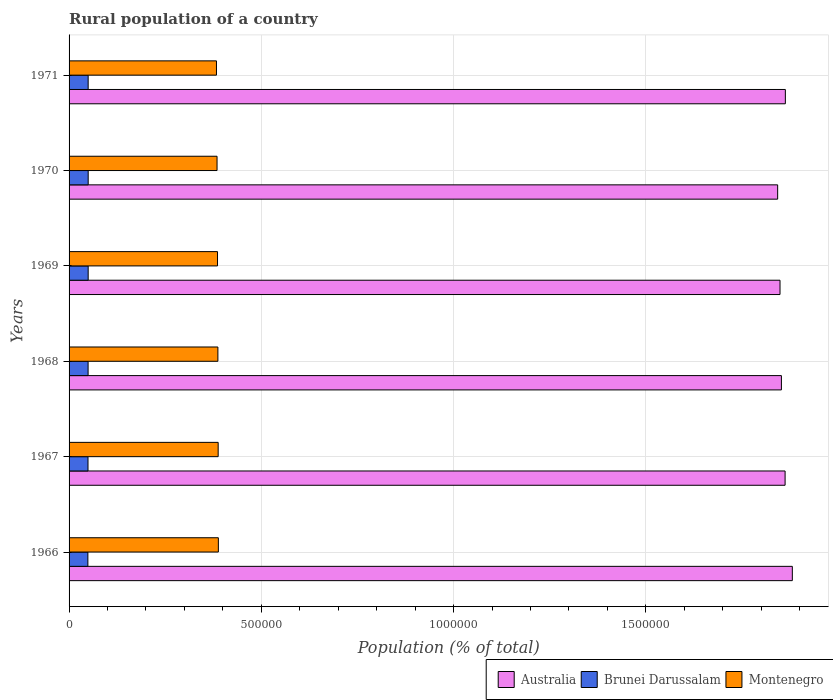How many groups of bars are there?
Make the answer very short. 6. Are the number of bars per tick equal to the number of legend labels?
Your answer should be very brief. Yes. How many bars are there on the 2nd tick from the bottom?
Keep it short and to the point. 3. What is the label of the 3rd group of bars from the top?
Provide a short and direct response. 1969. What is the rural population in Brunei Darussalam in 1970?
Your answer should be very brief. 4.97e+04. Across all years, what is the maximum rural population in Australia?
Give a very brief answer. 1.88e+06. Across all years, what is the minimum rural population in Brunei Darussalam?
Keep it short and to the point. 4.89e+04. In which year was the rural population in Montenegro maximum?
Give a very brief answer. 1966. In which year was the rural population in Australia minimum?
Give a very brief answer. 1970. What is the total rural population in Australia in the graph?
Give a very brief answer. 1.12e+07. What is the difference between the rural population in Brunei Darussalam in 1969 and that in 1970?
Your answer should be compact. -55. What is the difference between the rural population in Brunei Darussalam in 1969 and the rural population in Australia in 1968?
Your answer should be very brief. -1.80e+06. What is the average rural population in Brunei Darussalam per year?
Keep it short and to the point. 4.94e+04. In the year 1967, what is the difference between the rural population in Brunei Darussalam and rural population in Montenegro?
Your response must be concise. -3.39e+05. In how many years, is the rural population in Brunei Darussalam greater than 600000 %?
Make the answer very short. 0. What is the ratio of the rural population in Australia in 1967 to that in 1969?
Provide a short and direct response. 1.01. What is the difference between the highest and the second highest rural population in Montenegro?
Your answer should be compact. 488. What is the difference between the highest and the lowest rural population in Brunei Darussalam?
Your answer should be very brief. 796. In how many years, is the rural population in Australia greater than the average rural population in Australia taken over all years?
Give a very brief answer. 3. Is the sum of the rural population in Australia in 1969 and 1971 greater than the maximum rural population in Brunei Darussalam across all years?
Provide a short and direct response. Yes. What does the 2nd bar from the top in 1971 represents?
Keep it short and to the point. Brunei Darussalam. What does the 2nd bar from the bottom in 1967 represents?
Keep it short and to the point. Brunei Darussalam. Are all the bars in the graph horizontal?
Your answer should be compact. Yes. Where does the legend appear in the graph?
Keep it short and to the point. Bottom right. How are the legend labels stacked?
Keep it short and to the point. Horizontal. What is the title of the graph?
Your response must be concise. Rural population of a country. Does "Lao PDR" appear as one of the legend labels in the graph?
Give a very brief answer. No. What is the label or title of the X-axis?
Ensure brevity in your answer.  Population (% of total). What is the label or title of the Y-axis?
Your answer should be compact. Years. What is the Population (% of total) in Australia in 1966?
Your response must be concise. 1.88e+06. What is the Population (% of total) in Brunei Darussalam in 1966?
Offer a terse response. 4.89e+04. What is the Population (% of total) in Montenegro in 1966?
Offer a very short reply. 3.88e+05. What is the Population (% of total) of Australia in 1967?
Offer a very short reply. 1.86e+06. What is the Population (% of total) in Brunei Darussalam in 1967?
Your answer should be compact. 4.92e+04. What is the Population (% of total) in Montenegro in 1967?
Provide a short and direct response. 3.88e+05. What is the Population (% of total) in Australia in 1968?
Ensure brevity in your answer.  1.85e+06. What is the Population (% of total) of Brunei Darussalam in 1968?
Your answer should be compact. 4.95e+04. What is the Population (% of total) of Montenegro in 1968?
Ensure brevity in your answer.  3.87e+05. What is the Population (% of total) in Australia in 1969?
Your response must be concise. 1.85e+06. What is the Population (% of total) in Brunei Darussalam in 1969?
Your response must be concise. 4.97e+04. What is the Population (% of total) in Montenegro in 1969?
Provide a succinct answer. 3.86e+05. What is the Population (% of total) in Australia in 1970?
Your answer should be compact. 1.84e+06. What is the Population (% of total) in Brunei Darussalam in 1970?
Give a very brief answer. 4.97e+04. What is the Population (% of total) in Montenegro in 1970?
Your response must be concise. 3.85e+05. What is the Population (% of total) of Australia in 1971?
Keep it short and to the point. 1.86e+06. What is the Population (% of total) of Brunei Darussalam in 1971?
Your response must be concise. 4.97e+04. What is the Population (% of total) of Montenegro in 1971?
Offer a terse response. 3.83e+05. Across all years, what is the maximum Population (% of total) of Australia?
Give a very brief answer. 1.88e+06. Across all years, what is the maximum Population (% of total) in Brunei Darussalam?
Make the answer very short. 4.97e+04. Across all years, what is the maximum Population (% of total) of Montenegro?
Ensure brevity in your answer.  3.88e+05. Across all years, what is the minimum Population (% of total) in Australia?
Provide a short and direct response. 1.84e+06. Across all years, what is the minimum Population (% of total) of Brunei Darussalam?
Your answer should be very brief. 4.89e+04. Across all years, what is the minimum Population (% of total) of Montenegro?
Provide a succinct answer. 3.83e+05. What is the total Population (% of total) in Australia in the graph?
Your answer should be very brief. 1.12e+07. What is the total Population (% of total) in Brunei Darussalam in the graph?
Your answer should be compact. 2.97e+05. What is the total Population (% of total) in Montenegro in the graph?
Your answer should be compact. 2.32e+06. What is the difference between the Population (% of total) of Australia in 1966 and that in 1967?
Provide a short and direct response. 1.88e+04. What is the difference between the Population (% of total) of Brunei Darussalam in 1966 and that in 1967?
Offer a terse response. -318. What is the difference between the Population (% of total) of Montenegro in 1966 and that in 1967?
Give a very brief answer. 488. What is the difference between the Population (% of total) of Australia in 1966 and that in 1968?
Ensure brevity in your answer.  2.84e+04. What is the difference between the Population (% of total) in Brunei Darussalam in 1966 and that in 1968?
Provide a succinct answer. -571. What is the difference between the Population (% of total) of Montenegro in 1966 and that in 1968?
Provide a succinct answer. 1223. What is the difference between the Population (% of total) in Australia in 1966 and that in 1969?
Offer a terse response. 3.20e+04. What is the difference between the Population (% of total) of Brunei Darussalam in 1966 and that in 1969?
Make the answer very short. -741. What is the difference between the Population (% of total) in Montenegro in 1966 and that in 1969?
Ensure brevity in your answer.  2198. What is the difference between the Population (% of total) in Australia in 1966 and that in 1970?
Your answer should be very brief. 3.81e+04. What is the difference between the Population (% of total) of Brunei Darussalam in 1966 and that in 1970?
Keep it short and to the point. -796. What is the difference between the Population (% of total) of Montenegro in 1966 and that in 1970?
Provide a succinct answer. 3443. What is the difference between the Population (% of total) in Australia in 1966 and that in 1971?
Keep it short and to the point. 1.81e+04. What is the difference between the Population (% of total) of Brunei Darussalam in 1966 and that in 1971?
Keep it short and to the point. -733. What is the difference between the Population (% of total) of Montenegro in 1966 and that in 1971?
Offer a very short reply. 4952. What is the difference between the Population (% of total) of Australia in 1967 and that in 1968?
Your response must be concise. 9608. What is the difference between the Population (% of total) of Brunei Darussalam in 1967 and that in 1968?
Provide a short and direct response. -253. What is the difference between the Population (% of total) of Montenegro in 1967 and that in 1968?
Ensure brevity in your answer.  735. What is the difference between the Population (% of total) in Australia in 1967 and that in 1969?
Offer a very short reply. 1.32e+04. What is the difference between the Population (% of total) in Brunei Darussalam in 1967 and that in 1969?
Make the answer very short. -423. What is the difference between the Population (% of total) in Montenegro in 1967 and that in 1969?
Make the answer very short. 1710. What is the difference between the Population (% of total) in Australia in 1967 and that in 1970?
Provide a succinct answer. 1.93e+04. What is the difference between the Population (% of total) of Brunei Darussalam in 1967 and that in 1970?
Your response must be concise. -478. What is the difference between the Population (% of total) of Montenegro in 1967 and that in 1970?
Provide a succinct answer. 2955. What is the difference between the Population (% of total) of Australia in 1967 and that in 1971?
Provide a short and direct response. -692. What is the difference between the Population (% of total) of Brunei Darussalam in 1967 and that in 1971?
Give a very brief answer. -415. What is the difference between the Population (% of total) in Montenegro in 1967 and that in 1971?
Your response must be concise. 4464. What is the difference between the Population (% of total) in Australia in 1968 and that in 1969?
Your response must be concise. 3613. What is the difference between the Population (% of total) of Brunei Darussalam in 1968 and that in 1969?
Offer a very short reply. -170. What is the difference between the Population (% of total) of Montenegro in 1968 and that in 1969?
Make the answer very short. 975. What is the difference between the Population (% of total) in Australia in 1968 and that in 1970?
Provide a short and direct response. 9722. What is the difference between the Population (% of total) of Brunei Darussalam in 1968 and that in 1970?
Ensure brevity in your answer.  -225. What is the difference between the Population (% of total) of Montenegro in 1968 and that in 1970?
Offer a terse response. 2220. What is the difference between the Population (% of total) in Australia in 1968 and that in 1971?
Make the answer very short. -1.03e+04. What is the difference between the Population (% of total) in Brunei Darussalam in 1968 and that in 1971?
Offer a very short reply. -162. What is the difference between the Population (% of total) in Montenegro in 1968 and that in 1971?
Ensure brevity in your answer.  3729. What is the difference between the Population (% of total) of Australia in 1969 and that in 1970?
Your answer should be compact. 6109. What is the difference between the Population (% of total) of Brunei Darussalam in 1969 and that in 1970?
Make the answer very short. -55. What is the difference between the Population (% of total) in Montenegro in 1969 and that in 1970?
Make the answer very short. 1245. What is the difference between the Population (% of total) of Australia in 1969 and that in 1971?
Offer a very short reply. -1.39e+04. What is the difference between the Population (% of total) in Brunei Darussalam in 1969 and that in 1971?
Provide a succinct answer. 8. What is the difference between the Population (% of total) in Montenegro in 1969 and that in 1971?
Your answer should be compact. 2754. What is the difference between the Population (% of total) of Australia in 1970 and that in 1971?
Provide a short and direct response. -2.00e+04. What is the difference between the Population (% of total) in Brunei Darussalam in 1970 and that in 1971?
Offer a very short reply. 63. What is the difference between the Population (% of total) in Montenegro in 1970 and that in 1971?
Make the answer very short. 1509. What is the difference between the Population (% of total) of Australia in 1966 and the Population (% of total) of Brunei Darussalam in 1967?
Provide a succinct answer. 1.83e+06. What is the difference between the Population (% of total) in Australia in 1966 and the Population (% of total) in Montenegro in 1967?
Make the answer very short. 1.49e+06. What is the difference between the Population (% of total) of Brunei Darussalam in 1966 and the Population (% of total) of Montenegro in 1967?
Provide a short and direct response. -3.39e+05. What is the difference between the Population (% of total) of Australia in 1966 and the Population (% of total) of Brunei Darussalam in 1968?
Make the answer very short. 1.83e+06. What is the difference between the Population (% of total) of Australia in 1966 and the Population (% of total) of Montenegro in 1968?
Ensure brevity in your answer.  1.49e+06. What is the difference between the Population (% of total) in Brunei Darussalam in 1966 and the Population (% of total) in Montenegro in 1968?
Provide a short and direct response. -3.38e+05. What is the difference between the Population (% of total) in Australia in 1966 and the Population (% of total) in Brunei Darussalam in 1969?
Make the answer very short. 1.83e+06. What is the difference between the Population (% of total) of Australia in 1966 and the Population (% of total) of Montenegro in 1969?
Your answer should be compact. 1.49e+06. What is the difference between the Population (% of total) of Brunei Darussalam in 1966 and the Population (% of total) of Montenegro in 1969?
Your answer should be compact. -3.37e+05. What is the difference between the Population (% of total) in Australia in 1966 and the Population (% of total) in Brunei Darussalam in 1970?
Make the answer very short. 1.83e+06. What is the difference between the Population (% of total) of Australia in 1966 and the Population (% of total) of Montenegro in 1970?
Provide a short and direct response. 1.50e+06. What is the difference between the Population (% of total) in Brunei Darussalam in 1966 and the Population (% of total) in Montenegro in 1970?
Give a very brief answer. -3.36e+05. What is the difference between the Population (% of total) of Australia in 1966 and the Population (% of total) of Brunei Darussalam in 1971?
Make the answer very short. 1.83e+06. What is the difference between the Population (% of total) of Australia in 1966 and the Population (% of total) of Montenegro in 1971?
Your response must be concise. 1.50e+06. What is the difference between the Population (% of total) of Brunei Darussalam in 1966 and the Population (% of total) of Montenegro in 1971?
Give a very brief answer. -3.34e+05. What is the difference between the Population (% of total) in Australia in 1967 and the Population (% of total) in Brunei Darussalam in 1968?
Your answer should be compact. 1.81e+06. What is the difference between the Population (% of total) of Australia in 1967 and the Population (% of total) of Montenegro in 1968?
Make the answer very short. 1.48e+06. What is the difference between the Population (% of total) in Brunei Darussalam in 1967 and the Population (% of total) in Montenegro in 1968?
Offer a terse response. -3.38e+05. What is the difference between the Population (% of total) in Australia in 1967 and the Population (% of total) in Brunei Darussalam in 1969?
Keep it short and to the point. 1.81e+06. What is the difference between the Population (% of total) in Australia in 1967 and the Population (% of total) in Montenegro in 1969?
Provide a short and direct response. 1.48e+06. What is the difference between the Population (% of total) of Brunei Darussalam in 1967 and the Population (% of total) of Montenegro in 1969?
Provide a short and direct response. -3.37e+05. What is the difference between the Population (% of total) of Australia in 1967 and the Population (% of total) of Brunei Darussalam in 1970?
Provide a short and direct response. 1.81e+06. What is the difference between the Population (% of total) in Australia in 1967 and the Population (% of total) in Montenegro in 1970?
Your answer should be very brief. 1.48e+06. What is the difference between the Population (% of total) of Brunei Darussalam in 1967 and the Population (% of total) of Montenegro in 1970?
Your answer should be compact. -3.36e+05. What is the difference between the Population (% of total) in Australia in 1967 and the Population (% of total) in Brunei Darussalam in 1971?
Your response must be concise. 1.81e+06. What is the difference between the Population (% of total) of Australia in 1967 and the Population (% of total) of Montenegro in 1971?
Provide a short and direct response. 1.48e+06. What is the difference between the Population (% of total) in Brunei Darussalam in 1967 and the Population (% of total) in Montenegro in 1971?
Provide a succinct answer. -3.34e+05. What is the difference between the Population (% of total) of Australia in 1968 and the Population (% of total) of Brunei Darussalam in 1969?
Provide a succinct answer. 1.80e+06. What is the difference between the Population (% of total) in Australia in 1968 and the Population (% of total) in Montenegro in 1969?
Offer a very short reply. 1.47e+06. What is the difference between the Population (% of total) of Brunei Darussalam in 1968 and the Population (% of total) of Montenegro in 1969?
Your answer should be compact. -3.37e+05. What is the difference between the Population (% of total) of Australia in 1968 and the Population (% of total) of Brunei Darussalam in 1970?
Provide a short and direct response. 1.80e+06. What is the difference between the Population (% of total) in Australia in 1968 and the Population (% of total) in Montenegro in 1970?
Provide a short and direct response. 1.47e+06. What is the difference between the Population (% of total) of Brunei Darussalam in 1968 and the Population (% of total) of Montenegro in 1970?
Provide a succinct answer. -3.35e+05. What is the difference between the Population (% of total) in Australia in 1968 and the Population (% of total) in Brunei Darussalam in 1971?
Provide a short and direct response. 1.80e+06. What is the difference between the Population (% of total) of Australia in 1968 and the Population (% of total) of Montenegro in 1971?
Your answer should be very brief. 1.47e+06. What is the difference between the Population (% of total) in Brunei Darussalam in 1968 and the Population (% of total) in Montenegro in 1971?
Offer a very short reply. -3.34e+05. What is the difference between the Population (% of total) in Australia in 1969 and the Population (% of total) in Brunei Darussalam in 1970?
Make the answer very short. 1.80e+06. What is the difference between the Population (% of total) of Australia in 1969 and the Population (% of total) of Montenegro in 1970?
Your answer should be compact. 1.46e+06. What is the difference between the Population (% of total) in Brunei Darussalam in 1969 and the Population (% of total) in Montenegro in 1970?
Your answer should be very brief. -3.35e+05. What is the difference between the Population (% of total) in Australia in 1969 and the Population (% of total) in Brunei Darussalam in 1971?
Provide a succinct answer. 1.80e+06. What is the difference between the Population (% of total) in Australia in 1969 and the Population (% of total) in Montenegro in 1971?
Your answer should be very brief. 1.47e+06. What is the difference between the Population (% of total) in Brunei Darussalam in 1969 and the Population (% of total) in Montenegro in 1971?
Make the answer very short. -3.34e+05. What is the difference between the Population (% of total) in Australia in 1970 and the Population (% of total) in Brunei Darussalam in 1971?
Offer a terse response. 1.79e+06. What is the difference between the Population (% of total) of Australia in 1970 and the Population (% of total) of Montenegro in 1971?
Your response must be concise. 1.46e+06. What is the difference between the Population (% of total) in Brunei Darussalam in 1970 and the Population (% of total) in Montenegro in 1971?
Provide a short and direct response. -3.34e+05. What is the average Population (% of total) in Australia per year?
Make the answer very short. 1.86e+06. What is the average Population (% of total) of Brunei Darussalam per year?
Your answer should be compact. 4.94e+04. What is the average Population (% of total) of Montenegro per year?
Your response must be concise. 3.86e+05. In the year 1966, what is the difference between the Population (% of total) in Australia and Population (% of total) in Brunei Darussalam?
Make the answer very short. 1.83e+06. In the year 1966, what is the difference between the Population (% of total) of Australia and Population (% of total) of Montenegro?
Keep it short and to the point. 1.49e+06. In the year 1966, what is the difference between the Population (% of total) of Brunei Darussalam and Population (% of total) of Montenegro?
Provide a short and direct response. -3.39e+05. In the year 1967, what is the difference between the Population (% of total) of Australia and Population (% of total) of Brunei Darussalam?
Your answer should be compact. 1.81e+06. In the year 1967, what is the difference between the Population (% of total) in Australia and Population (% of total) in Montenegro?
Make the answer very short. 1.47e+06. In the year 1967, what is the difference between the Population (% of total) in Brunei Darussalam and Population (% of total) in Montenegro?
Ensure brevity in your answer.  -3.39e+05. In the year 1968, what is the difference between the Population (% of total) in Australia and Population (% of total) in Brunei Darussalam?
Your response must be concise. 1.80e+06. In the year 1968, what is the difference between the Population (% of total) of Australia and Population (% of total) of Montenegro?
Ensure brevity in your answer.  1.47e+06. In the year 1968, what is the difference between the Population (% of total) of Brunei Darussalam and Population (% of total) of Montenegro?
Give a very brief answer. -3.38e+05. In the year 1969, what is the difference between the Population (% of total) in Australia and Population (% of total) in Brunei Darussalam?
Offer a very short reply. 1.80e+06. In the year 1969, what is the difference between the Population (% of total) in Australia and Population (% of total) in Montenegro?
Provide a short and direct response. 1.46e+06. In the year 1969, what is the difference between the Population (% of total) of Brunei Darussalam and Population (% of total) of Montenegro?
Offer a terse response. -3.36e+05. In the year 1970, what is the difference between the Population (% of total) of Australia and Population (% of total) of Brunei Darussalam?
Keep it short and to the point. 1.79e+06. In the year 1970, what is the difference between the Population (% of total) in Australia and Population (% of total) in Montenegro?
Your answer should be very brief. 1.46e+06. In the year 1970, what is the difference between the Population (% of total) in Brunei Darussalam and Population (% of total) in Montenegro?
Your answer should be compact. -3.35e+05. In the year 1971, what is the difference between the Population (% of total) of Australia and Population (% of total) of Brunei Darussalam?
Give a very brief answer. 1.81e+06. In the year 1971, what is the difference between the Population (% of total) of Australia and Population (% of total) of Montenegro?
Offer a terse response. 1.48e+06. In the year 1971, what is the difference between the Population (% of total) in Brunei Darussalam and Population (% of total) in Montenegro?
Give a very brief answer. -3.34e+05. What is the ratio of the Population (% of total) of Australia in 1966 to that in 1967?
Your response must be concise. 1.01. What is the ratio of the Population (% of total) in Montenegro in 1966 to that in 1967?
Your answer should be very brief. 1. What is the ratio of the Population (% of total) of Australia in 1966 to that in 1968?
Your answer should be compact. 1.02. What is the ratio of the Population (% of total) in Brunei Darussalam in 1966 to that in 1968?
Offer a terse response. 0.99. What is the ratio of the Population (% of total) of Australia in 1966 to that in 1969?
Offer a very short reply. 1.02. What is the ratio of the Population (% of total) of Brunei Darussalam in 1966 to that in 1969?
Give a very brief answer. 0.99. What is the ratio of the Population (% of total) of Montenegro in 1966 to that in 1969?
Make the answer very short. 1.01. What is the ratio of the Population (% of total) in Australia in 1966 to that in 1970?
Provide a succinct answer. 1.02. What is the ratio of the Population (% of total) in Montenegro in 1966 to that in 1970?
Give a very brief answer. 1.01. What is the ratio of the Population (% of total) of Australia in 1966 to that in 1971?
Offer a very short reply. 1.01. What is the ratio of the Population (% of total) in Brunei Darussalam in 1966 to that in 1971?
Offer a very short reply. 0.99. What is the ratio of the Population (% of total) in Montenegro in 1966 to that in 1971?
Keep it short and to the point. 1.01. What is the ratio of the Population (% of total) in Australia in 1967 to that in 1968?
Ensure brevity in your answer.  1.01. What is the ratio of the Population (% of total) of Brunei Darussalam in 1967 to that in 1969?
Keep it short and to the point. 0.99. What is the ratio of the Population (% of total) in Australia in 1967 to that in 1970?
Offer a terse response. 1.01. What is the ratio of the Population (% of total) in Brunei Darussalam in 1967 to that in 1970?
Provide a succinct answer. 0.99. What is the ratio of the Population (% of total) of Montenegro in 1967 to that in 1970?
Provide a succinct answer. 1.01. What is the ratio of the Population (% of total) of Australia in 1967 to that in 1971?
Keep it short and to the point. 1. What is the ratio of the Population (% of total) of Brunei Darussalam in 1967 to that in 1971?
Provide a short and direct response. 0.99. What is the ratio of the Population (% of total) in Montenegro in 1967 to that in 1971?
Give a very brief answer. 1.01. What is the ratio of the Population (% of total) in Australia in 1968 to that in 1969?
Your answer should be very brief. 1. What is the ratio of the Population (% of total) in Montenegro in 1968 to that in 1970?
Keep it short and to the point. 1.01. What is the ratio of the Population (% of total) of Australia in 1968 to that in 1971?
Keep it short and to the point. 0.99. What is the ratio of the Population (% of total) of Brunei Darussalam in 1968 to that in 1971?
Keep it short and to the point. 1. What is the ratio of the Population (% of total) of Montenegro in 1968 to that in 1971?
Make the answer very short. 1.01. What is the ratio of the Population (% of total) of Australia in 1969 to that in 1970?
Make the answer very short. 1. What is the ratio of the Population (% of total) of Montenegro in 1969 to that in 1970?
Make the answer very short. 1. What is the ratio of the Population (% of total) in Australia in 1969 to that in 1971?
Your response must be concise. 0.99. What is the ratio of the Population (% of total) of Montenegro in 1969 to that in 1971?
Keep it short and to the point. 1.01. What is the ratio of the Population (% of total) in Australia in 1970 to that in 1971?
Provide a succinct answer. 0.99. What is the difference between the highest and the second highest Population (% of total) of Australia?
Provide a succinct answer. 1.81e+04. What is the difference between the highest and the second highest Population (% of total) of Brunei Darussalam?
Provide a short and direct response. 55. What is the difference between the highest and the second highest Population (% of total) in Montenegro?
Provide a short and direct response. 488. What is the difference between the highest and the lowest Population (% of total) of Australia?
Offer a very short reply. 3.81e+04. What is the difference between the highest and the lowest Population (% of total) of Brunei Darussalam?
Offer a very short reply. 796. What is the difference between the highest and the lowest Population (% of total) of Montenegro?
Keep it short and to the point. 4952. 